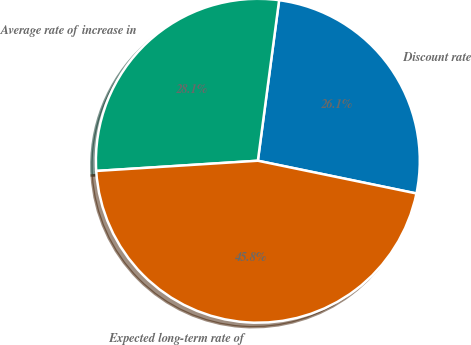<chart> <loc_0><loc_0><loc_500><loc_500><pie_chart><fcel>Discount rate<fcel>Average rate of increase in<fcel>Expected long-term rate of<nl><fcel>26.14%<fcel>28.1%<fcel>45.75%<nl></chart> 